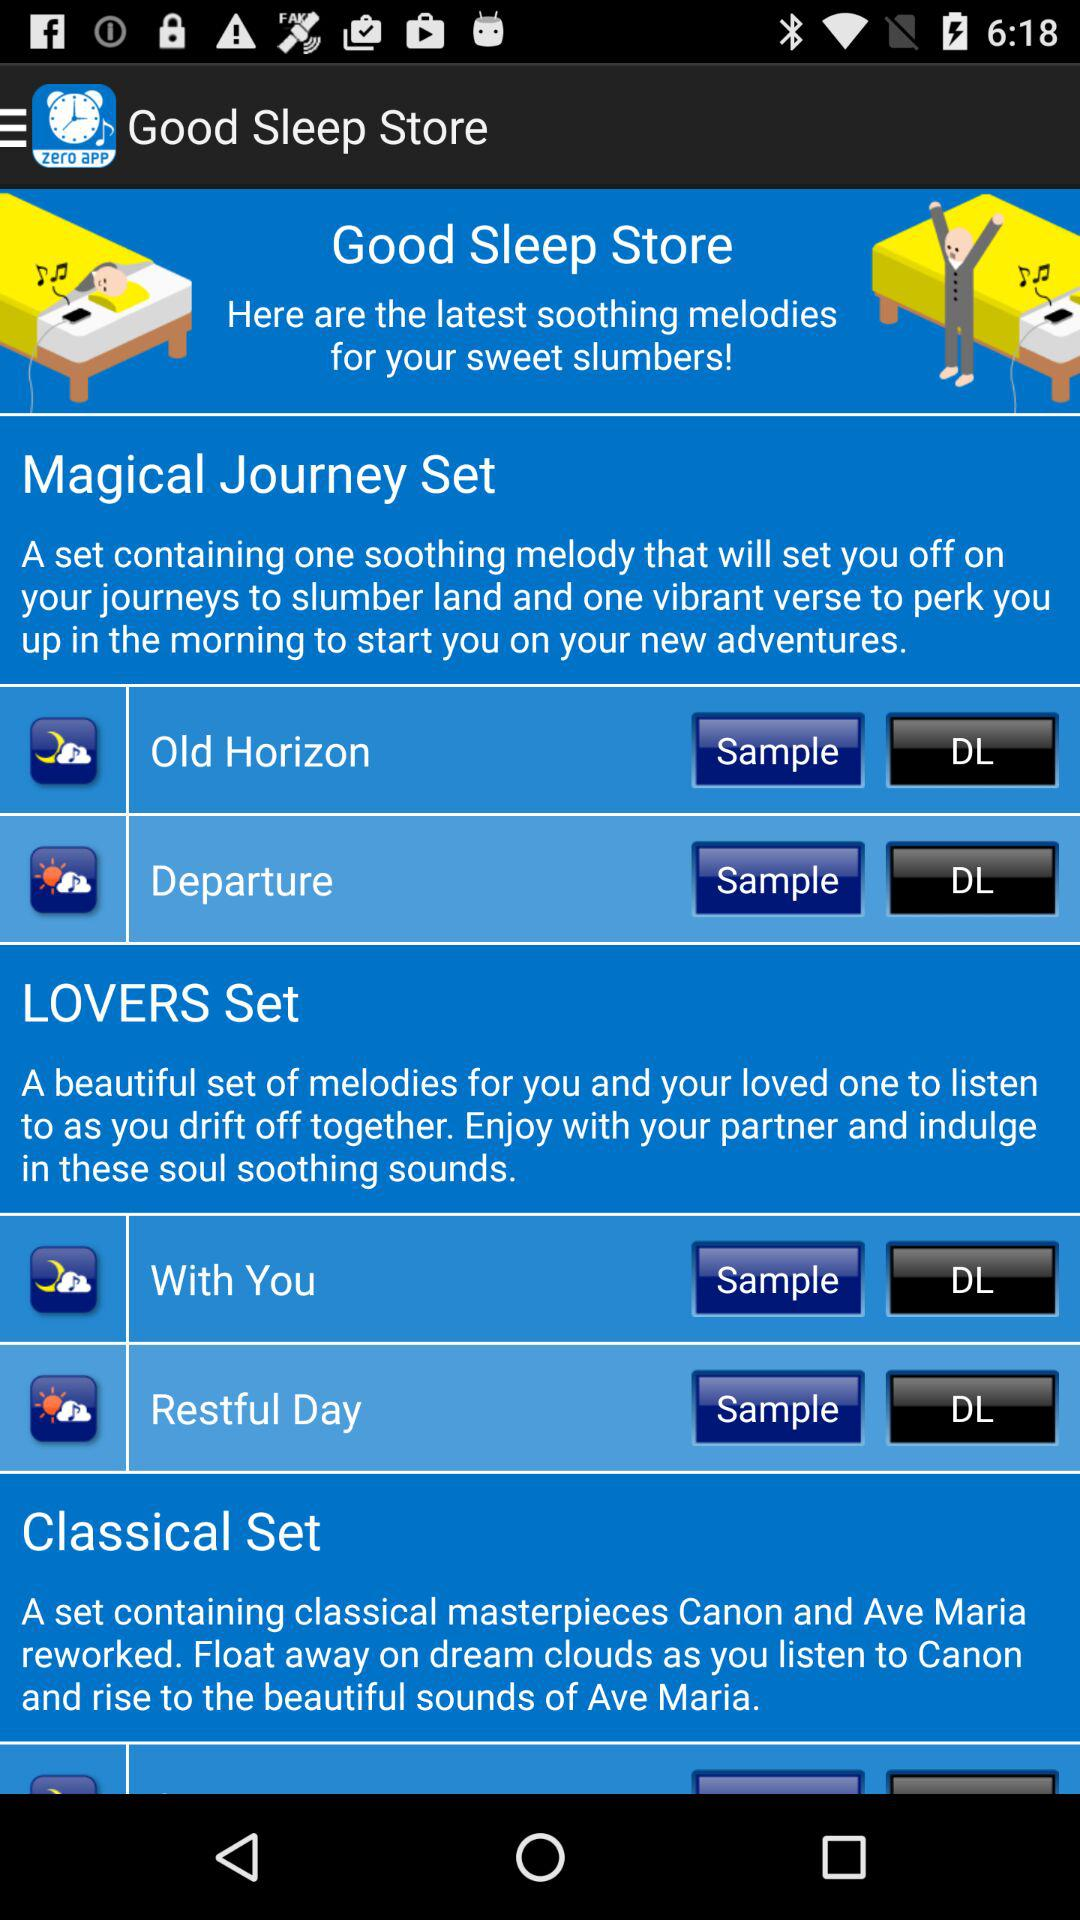What is the application name? The application name is "Good Sleep Store". 